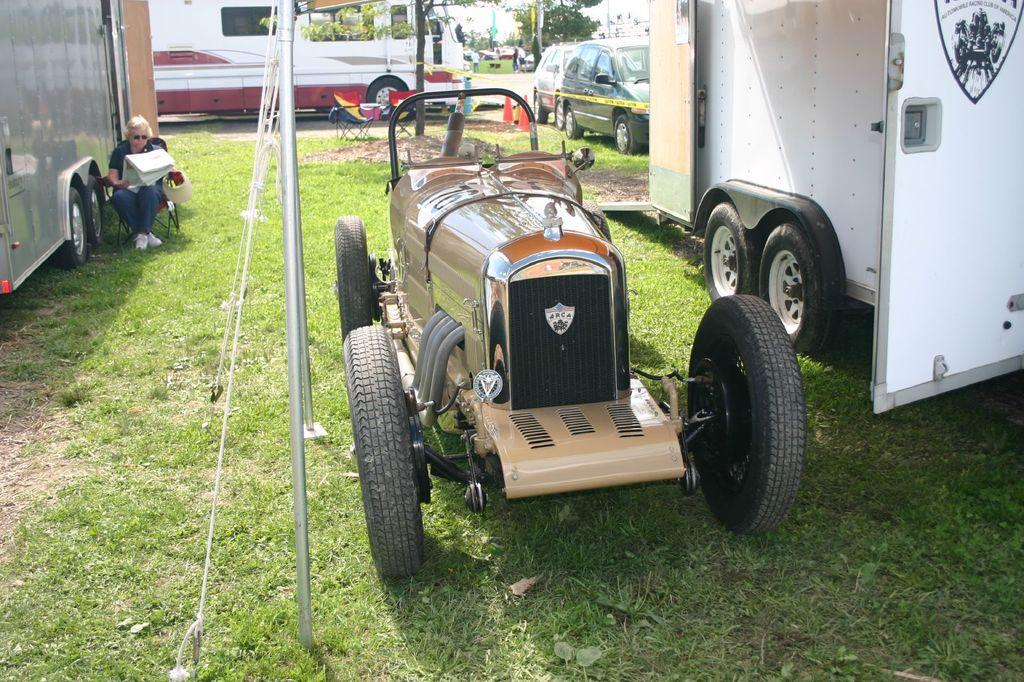What types of vehicles can be seen in the image? There are vehicles in the image, but the specific types are not mentioned. What is the natural environment like in the image? There is green grass and trees visible in the image. What safety equipment is present in the image? Traffic cones are present in the image. What are the poles used for in the image? The purpose of the poles is not mentioned in the facts. What are the ropes used for in the image? The purpose of the ropes is not mentioned in the facts. What is the person in the image doing? The person is sitting on a chair in the image and holding something. Can you see any squirrels playing on the sheet in the image? There is no sheet or squirrels present in the image. What subject is the person teaching in the image? There is no indication of a school or teaching in the image. 